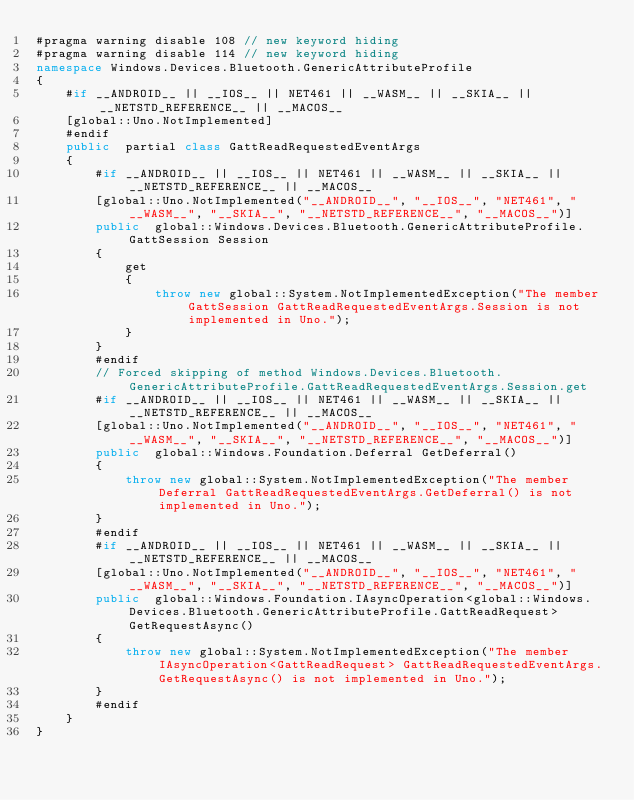Convert code to text. <code><loc_0><loc_0><loc_500><loc_500><_C#_>#pragma warning disable 108 // new keyword hiding
#pragma warning disable 114 // new keyword hiding
namespace Windows.Devices.Bluetooth.GenericAttributeProfile
{
	#if __ANDROID__ || __IOS__ || NET461 || __WASM__ || __SKIA__ || __NETSTD_REFERENCE__ || __MACOS__
	[global::Uno.NotImplemented]
	#endif
	public  partial class GattReadRequestedEventArgs 
	{
		#if __ANDROID__ || __IOS__ || NET461 || __WASM__ || __SKIA__ || __NETSTD_REFERENCE__ || __MACOS__
		[global::Uno.NotImplemented("__ANDROID__", "__IOS__", "NET461", "__WASM__", "__SKIA__", "__NETSTD_REFERENCE__", "__MACOS__")]
		public  global::Windows.Devices.Bluetooth.GenericAttributeProfile.GattSession Session
		{
			get
			{
				throw new global::System.NotImplementedException("The member GattSession GattReadRequestedEventArgs.Session is not implemented in Uno.");
			}
		}
		#endif
		// Forced skipping of method Windows.Devices.Bluetooth.GenericAttributeProfile.GattReadRequestedEventArgs.Session.get
		#if __ANDROID__ || __IOS__ || NET461 || __WASM__ || __SKIA__ || __NETSTD_REFERENCE__ || __MACOS__
		[global::Uno.NotImplemented("__ANDROID__", "__IOS__", "NET461", "__WASM__", "__SKIA__", "__NETSTD_REFERENCE__", "__MACOS__")]
		public  global::Windows.Foundation.Deferral GetDeferral()
		{
			throw new global::System.NotImplementedException("The member Deferral GattReadRequestedEventArgs.GetDeferral() is not implemented in Uno.");
		}
		#endif
		#if __ANDROID__ || __IOS__ || NET461 || __WASM__ || __SKIA__ || __NETSTD_REFERENCE__ || __MACOS__
		[global::Uno.NotImplemented("__ANDROID__", "__IOS__", "NET461", "__WASM__", "__SKIA__", "__NETSTD_REFERENCE__", "__MACOS__")]
		public  global::Windows.Foundation.IAsyncOperation<global::Windows.Devices.Bluetooth.GenericAttributeProfile.GattReadRequest> GetRequestAsync()
		{
			throw new global::System.NotImplementedException("The member IAsyncOperation<GattReadRequest> GattReadRequestedEventArgs.GetRequestAsync() is not implemented in Uno.");
		}
		#endif
	}
}
</code> 